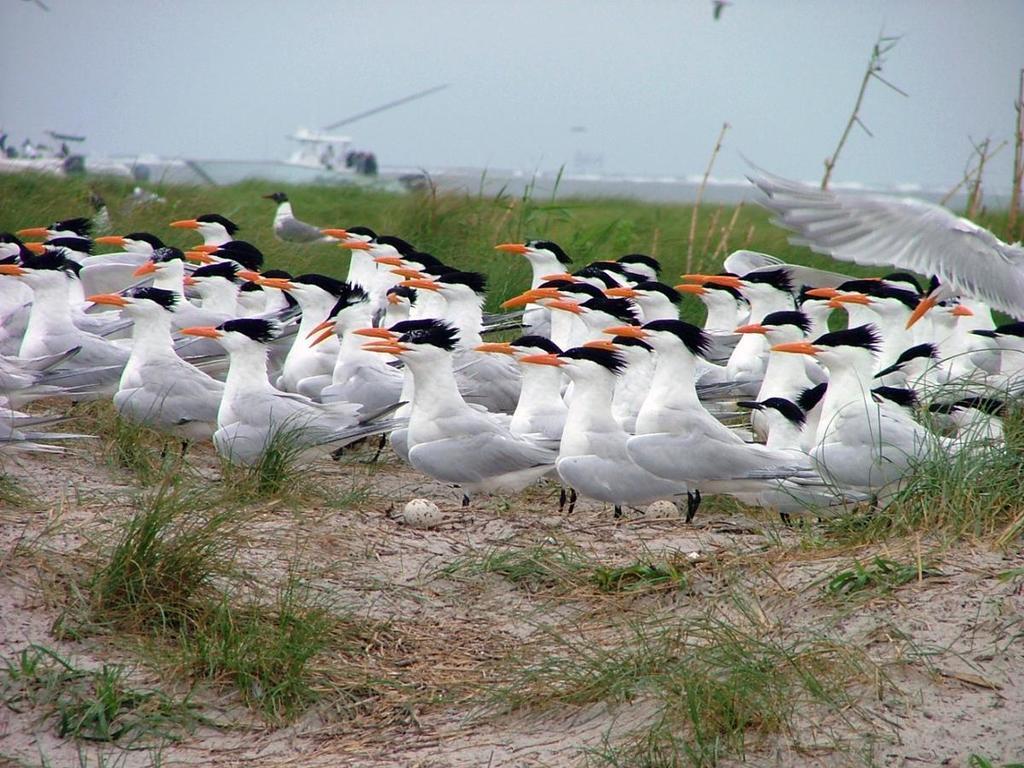Can you describe this image briefly? In this image there are birds. At the bottom of the image there is grass on the surface. In the background of the image there are ships in the water. On the top of the image there is sky. 